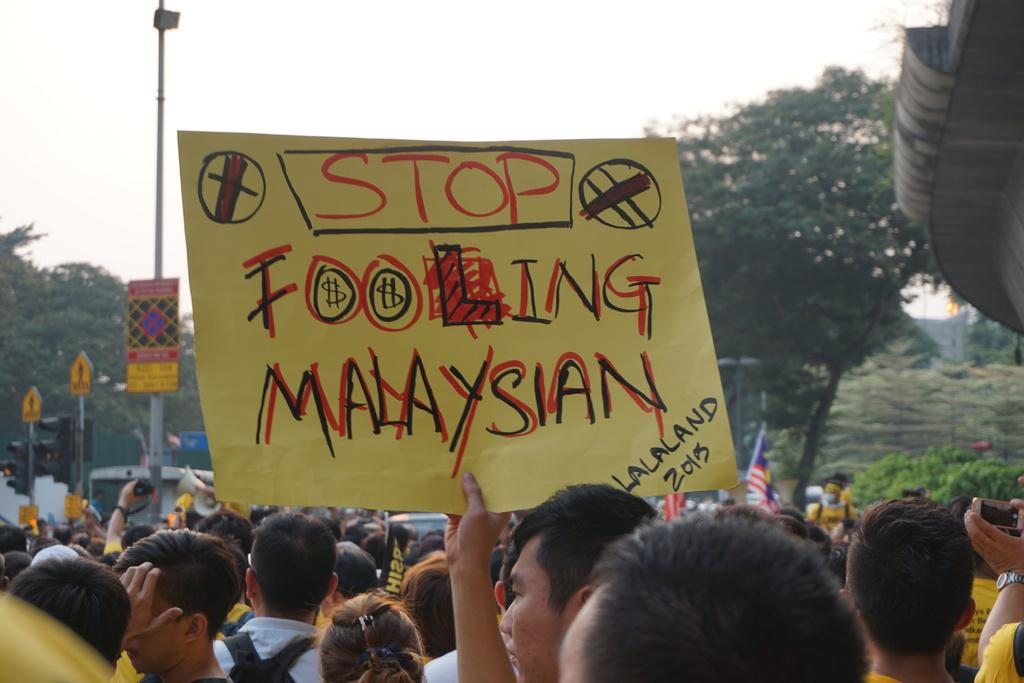What is the main subject in the middle of the image? There is an advertisement in the middle of the image. What can be seen in the background of the image? There are persons standing, poles, a CCTV camera, trees, hills, and the sky visible in the background of the image. How does the person in the image get a haircut? There is no person getting a haircut in the image; the focus is on the advertisement and the background elements. 